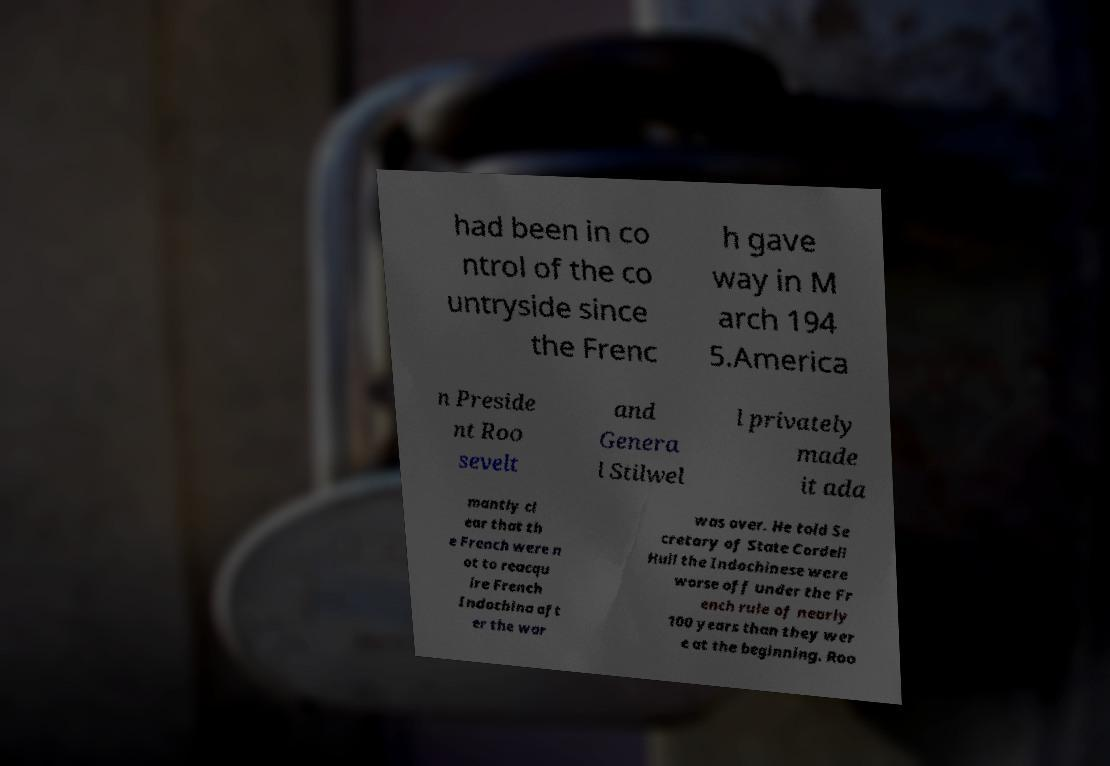Could you assist in decoding the text presented in this image and type it out clearly? had been in co ntrol of the co untryside since the Frenc h gave way in M arch 194 5.America n Preside nt Roo sevelt and Genera l Stilwel l privately made it ada mantly cl ear that th e French were n ot to reacqu ire French Indochina aft er the war was over. He told Se cretary of State Cordell Hull the Indochinese were worse off under the Fr ench rule of nearly 100 years than they wer e at the beginning. Roo 